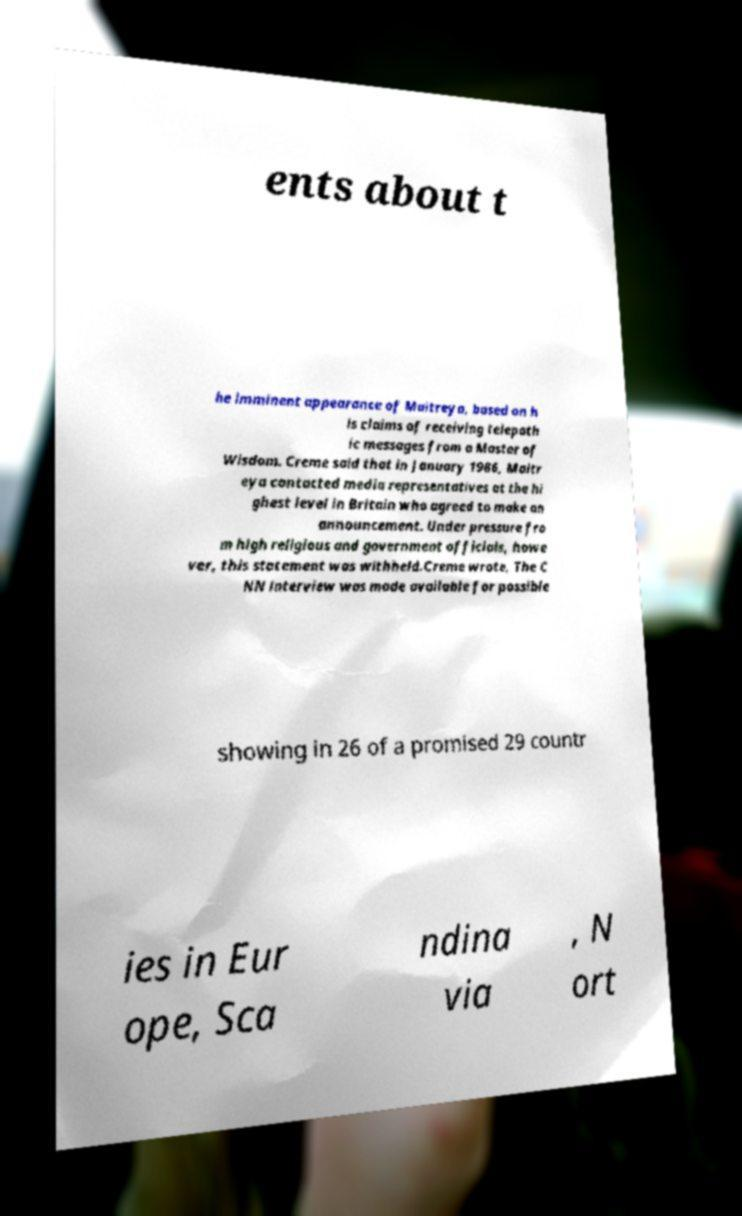Could you assist in decoding the text presented in this image and type it out clearly? ents about t he imminent appearance of Maitreya, based on h is claims of receiving telepath ic messages from a Master of Wisdom. Creme said that in January 1986, Maitr eya contacted media representatives at the hi ghest level in Britain who agreed to make an announcement. Under pressure fro m high religious and government officials, howe ver, this statement was withheld.Creme wrote, The C NN interview was made available for possible showing in 26 of a promised 29 countr ies in Eur ope, Sca ndina via , N ort 